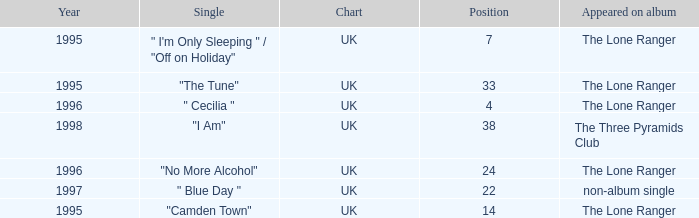After 1996, what is the average position? 30.0. 